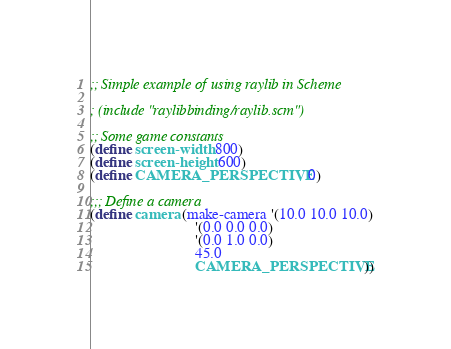Convert code to text. <code><loc_0><loc_0><loc_500><loc_500><_Scheme_>;; Simple example of using raylib in Scheme

; (include "raylibbinding/raylib.scm")

;; Some game constants 
(define screen-width 800)
(define screen-height 600)
(define CAMERA_PERSPECTIVE 0)

;;; Define a camera
(define camera (make-camera '(10.0 10.0 10.0)
                            '(0.0 0.0 0.0)
                            '(0.0 1.0 0.0)
                            45.0
                            CAMERA_PERSPECTIVE))</code> 